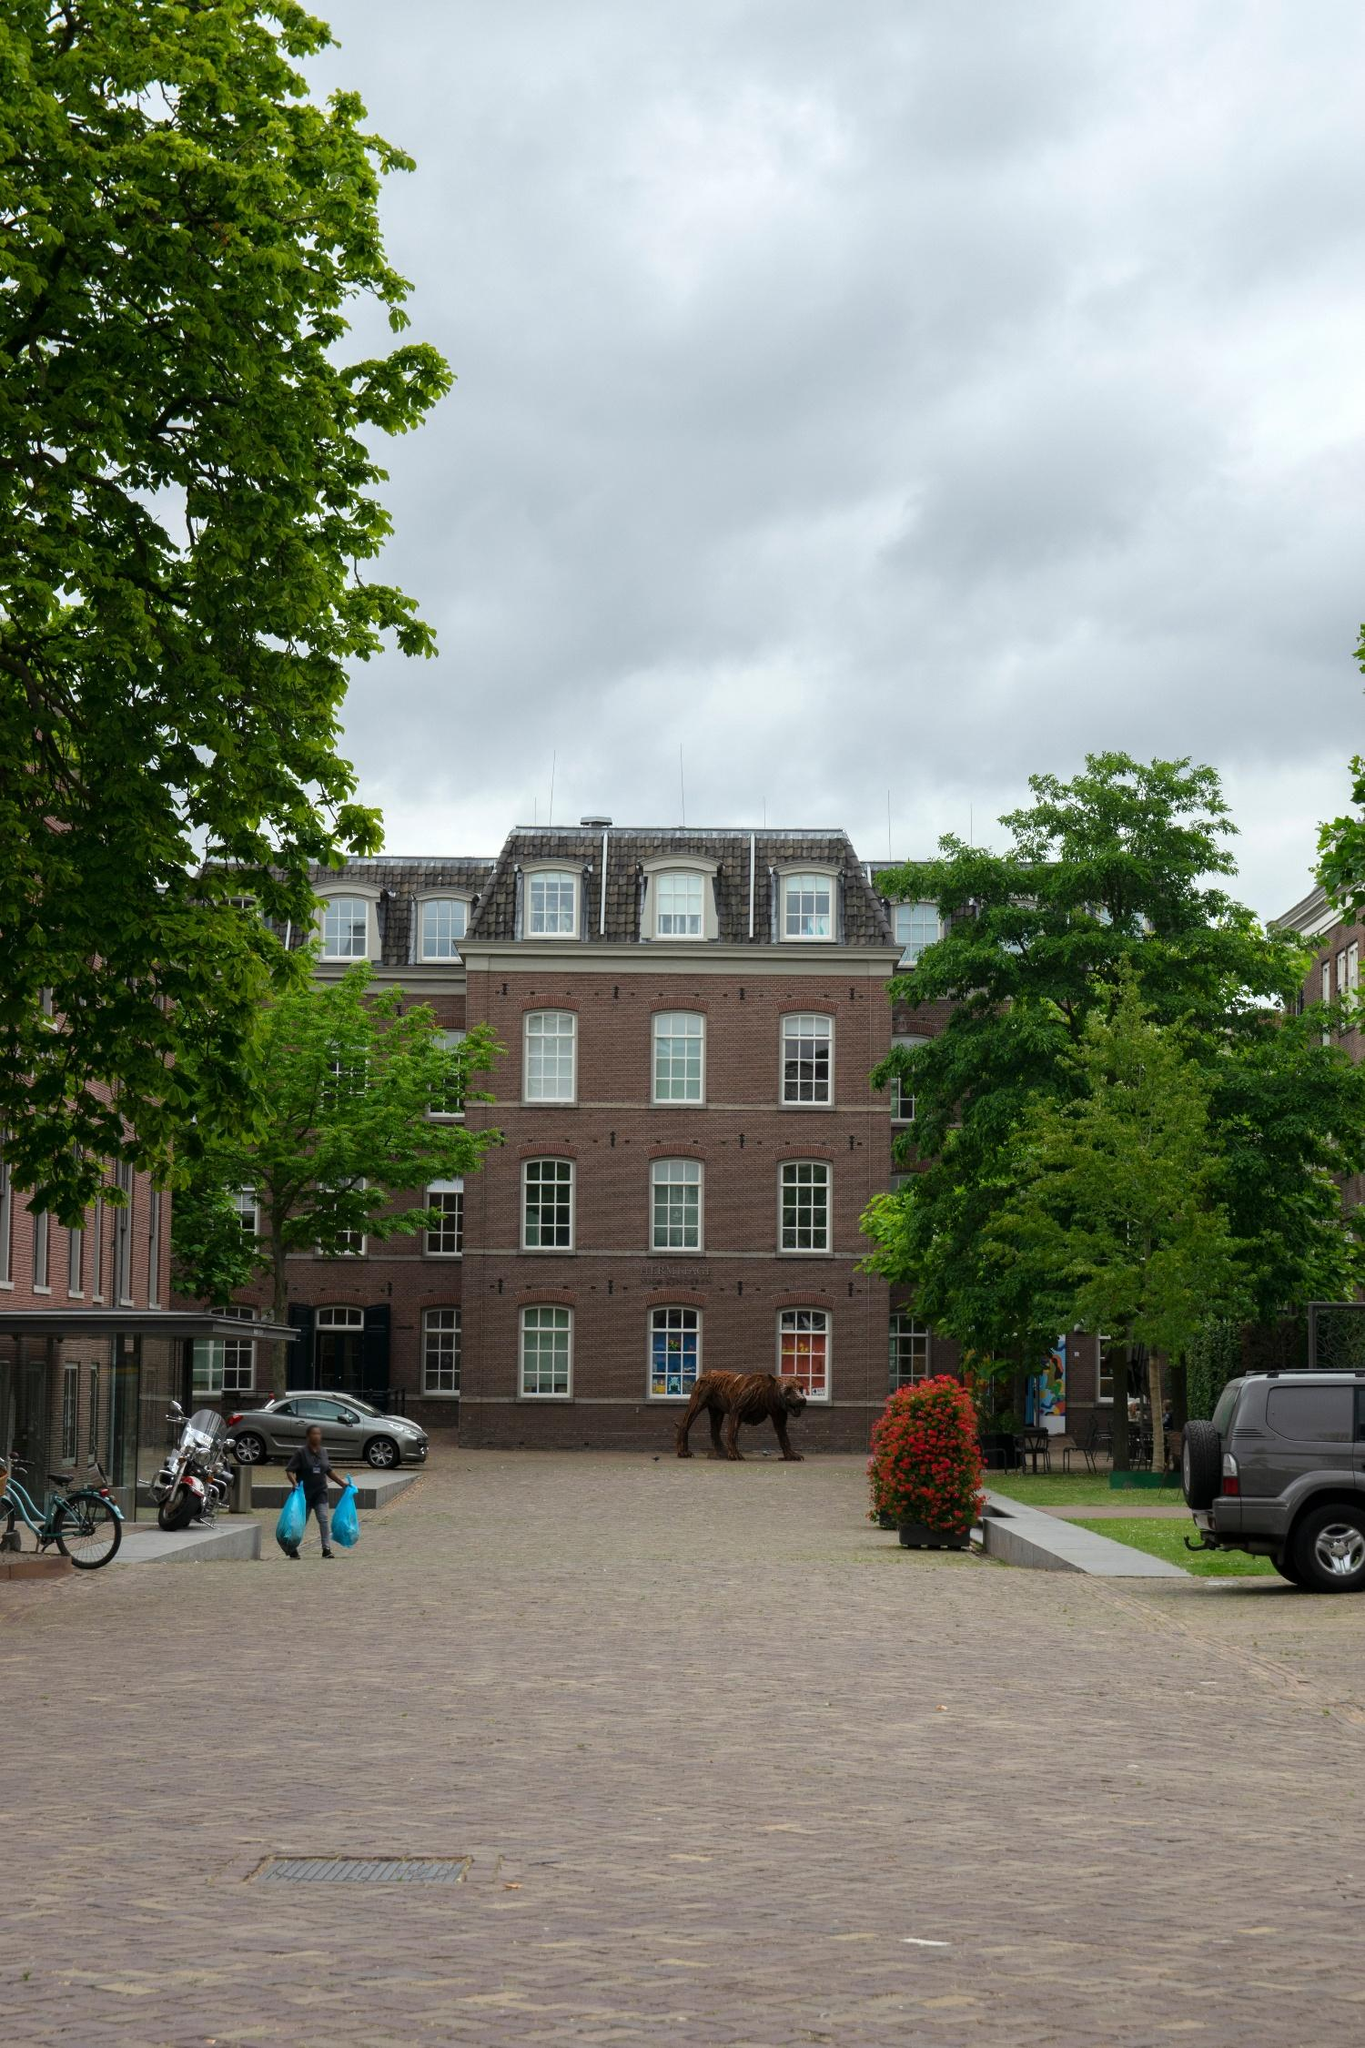What do you think is going on in this snapshot? In the image, there stands an elegant three-story brick building painted in red with charming white trim. This building boasts a distinctive mansard roof and is decorated with six windows on both the second and third floors, and three on the first floor, each window graced with white outlines and black shutters. The building graces a quaint brick-paved street that extends into a matching brick sidewalk, providing a vintage feel. To the left, a large verdant tree enhances the building’s picturesque scenery, while to the right, a smaller one adds balance to the scene. A black SUV is parked on the right, offering a modern contrast, while a bicycle leans casually on the left, embodying a slower pace of life. A person is seen walking down the sidewalk on the left, carrying on with their day. A striking brown sculpture of a bear stands on the sidewalk in front of the building, adding a touch of art and whimsy to the idyllic setting. Above, dramatic clouds fill the sky, perhaps suggesting the imminence of rain or simply a contemplative atmosphere. 